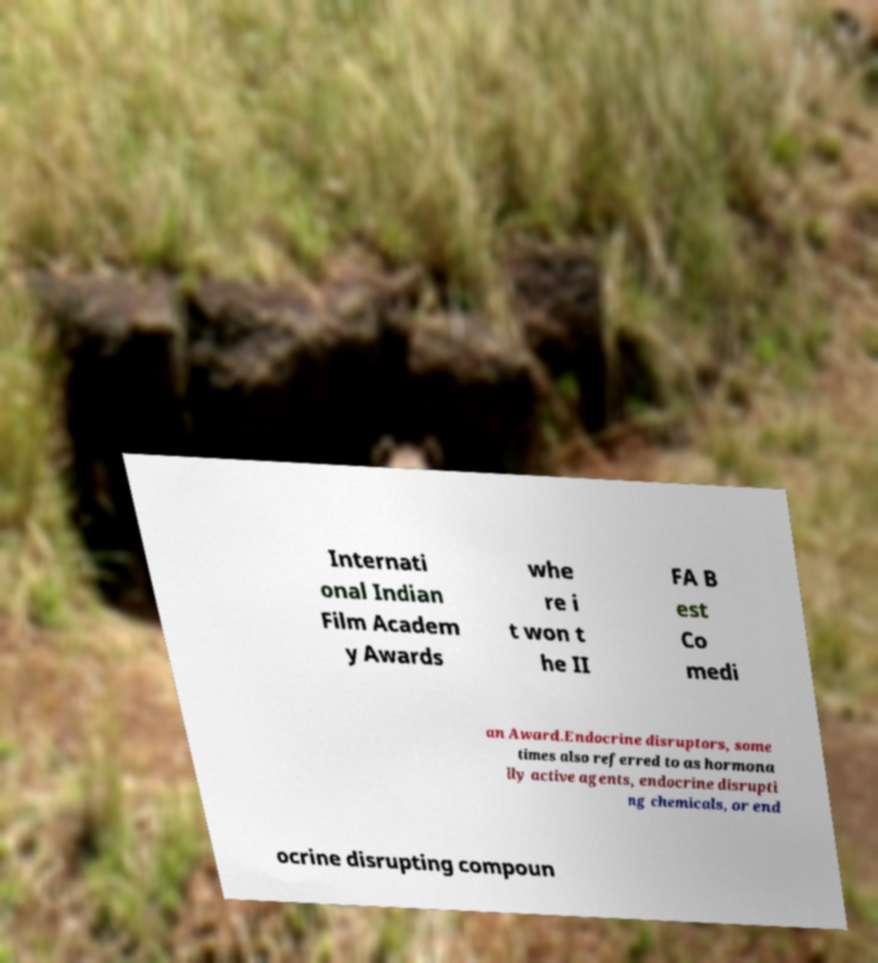There's text embedded in this image that I need extracted. Can you transcribe it verbatim? Internati onal Indian Film Academ y Awards whe re i t won t he II FA B est Co medi an Award.Endocrine disruptors, some times also referred to as hormona lly active agents, endocrine disrupti ng chemicals, or end ocrine disrupting compoun 